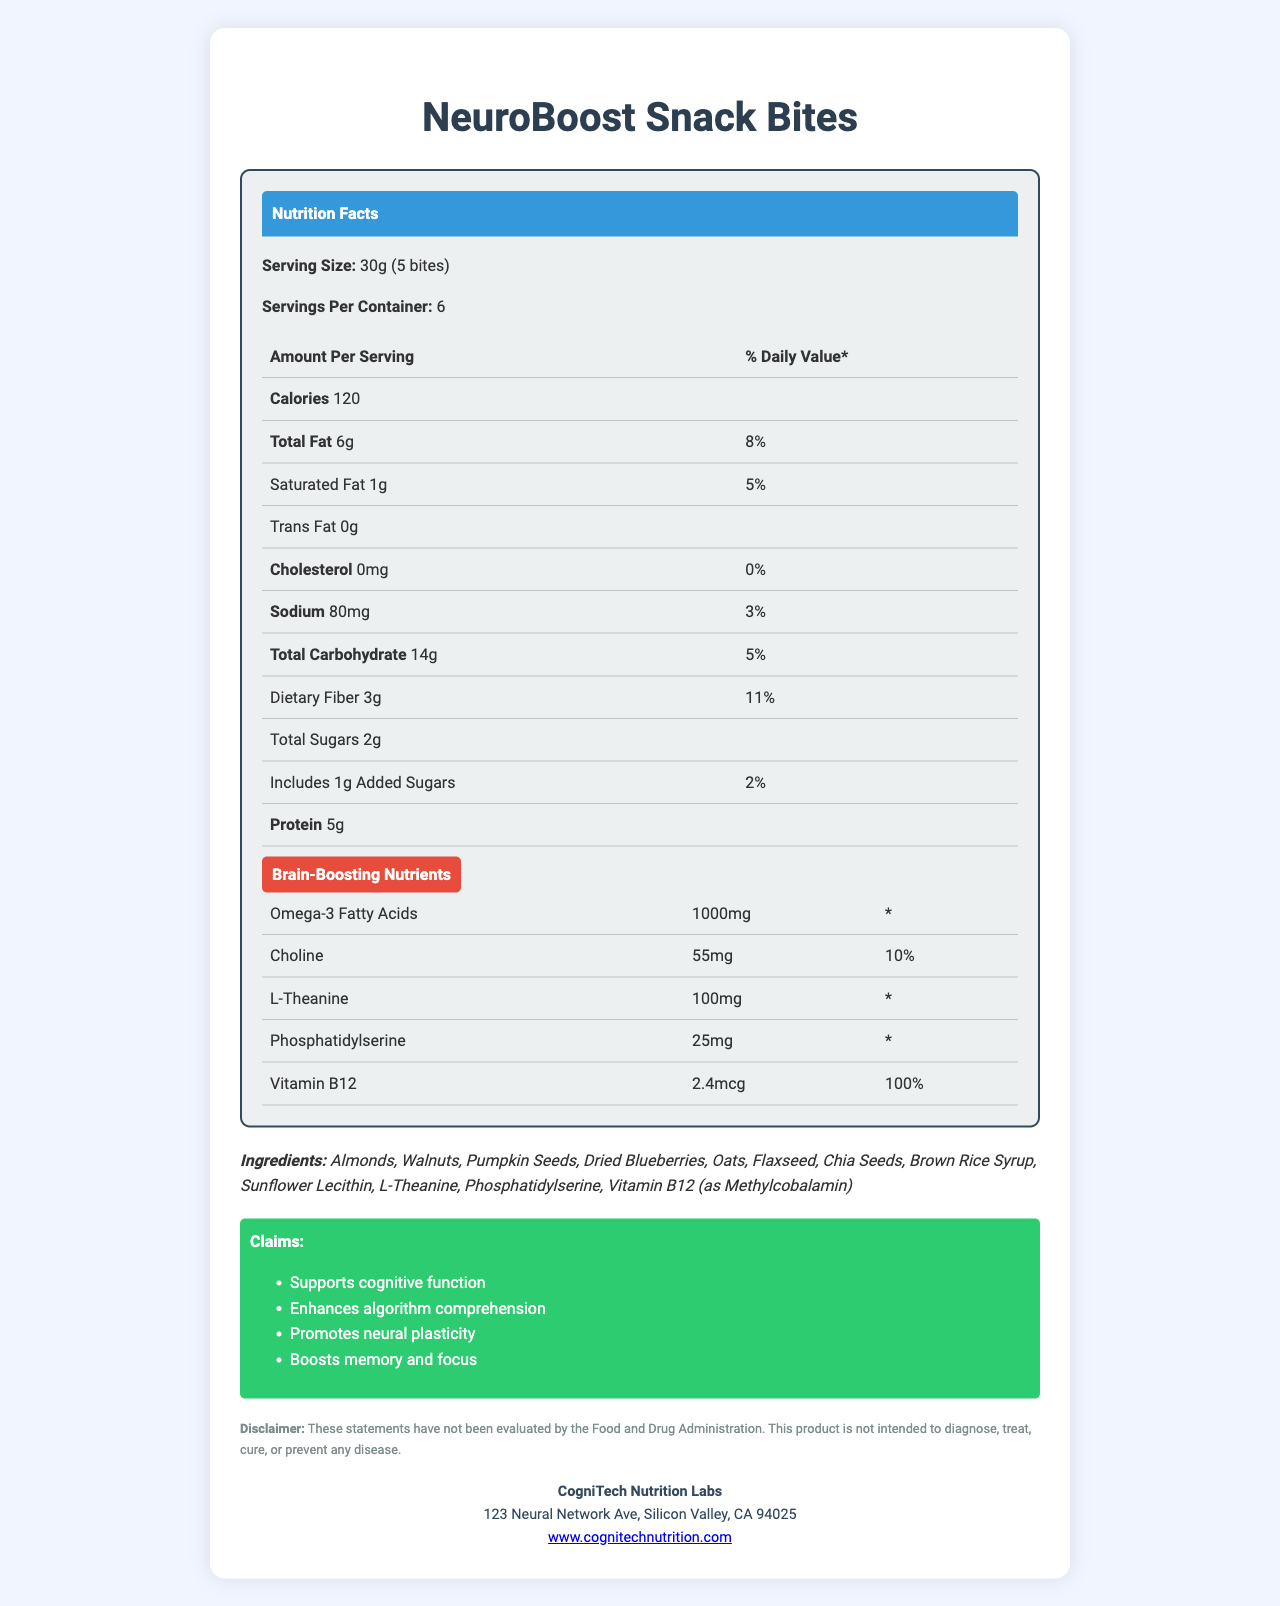when it comes to total fat content, how much is in a serving? The document states that each serving contains 6 grams of total fat.
Answer: 6g What percentage of the daily value of iron does one serving provide? The nutrition facts table lists iron content as 1.8mg, with a 10% daily value per serving.
Answer: 10% how many servings are in each container? The document indicates that there are 6 servings per container.
Answer: 6 What is the daily value percentage for dietary fiber in one serving? The document shows that one serving contains 3 grams of dietary fiber, which is 11% of the daily value.
Answer: 11% how many milligrams of omega-3 fatty acids are in one serving? One serving of the snack contains 1000 milligrams of omega-3 fatty acids.
Answer: 1000mg which of the following nutrients has the highest daily value percentage in one serving?  
A. Choline  
B. Vitamin B12  
C. Protein  
D. Dietary Fiber Vitamin B12 has a 100% daily value in one serving compared to other options.
Answer: B which of the following ingredients is not listed on the label?  
I. Almonds  
II. Walnuts  
III. Peanuts  
IV. Flaxseed The ingredient list includes almonds, walnuts, and flaxseed, but not peanuts.
Answer: III Does the product contain any added sugars? The document notes that there is 1 gram of added sugars per serving.
Answer: Yes Is the snack food intended to diagnose, treat, cure, or prevent any disease? The disclaimer explicitly states that the product is not intended to diagnose, treat, cure, or prevent any disease.
Answer: No Summarize the main nutritional and health-related features of this document. The summary integrates various pieces of data from the document including nutrient content, health claims, and ethical considerations.
Answer: NeuroBoost Snack Bites are marketed for cognitive benefits and enhancing algorithm comprehension. They contain key nutrients like omega-3 fatty acids, choline, L-Theanine, phosphatidylserine, and vitamin B12. Each serving provides 120 calories, 6g of total fat, 5g of protein, and 3g of dietary fiber. The product makes claims about supporting cognitive function and memory, though these claims are not FDA-evaluated. It also includes an ethical statement about the sourcing of ingredients. What is the product's price? The document does not mention the cost of the product, rendering us unable to determine its price from the provided information.
Answer: Not enough information 